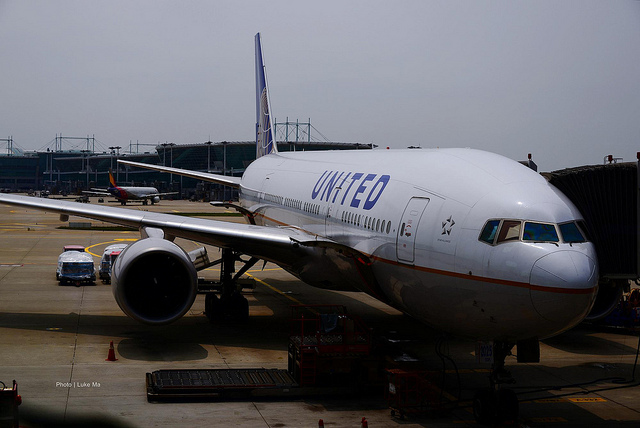Identify the text displayed in this image. UNITED Photo 